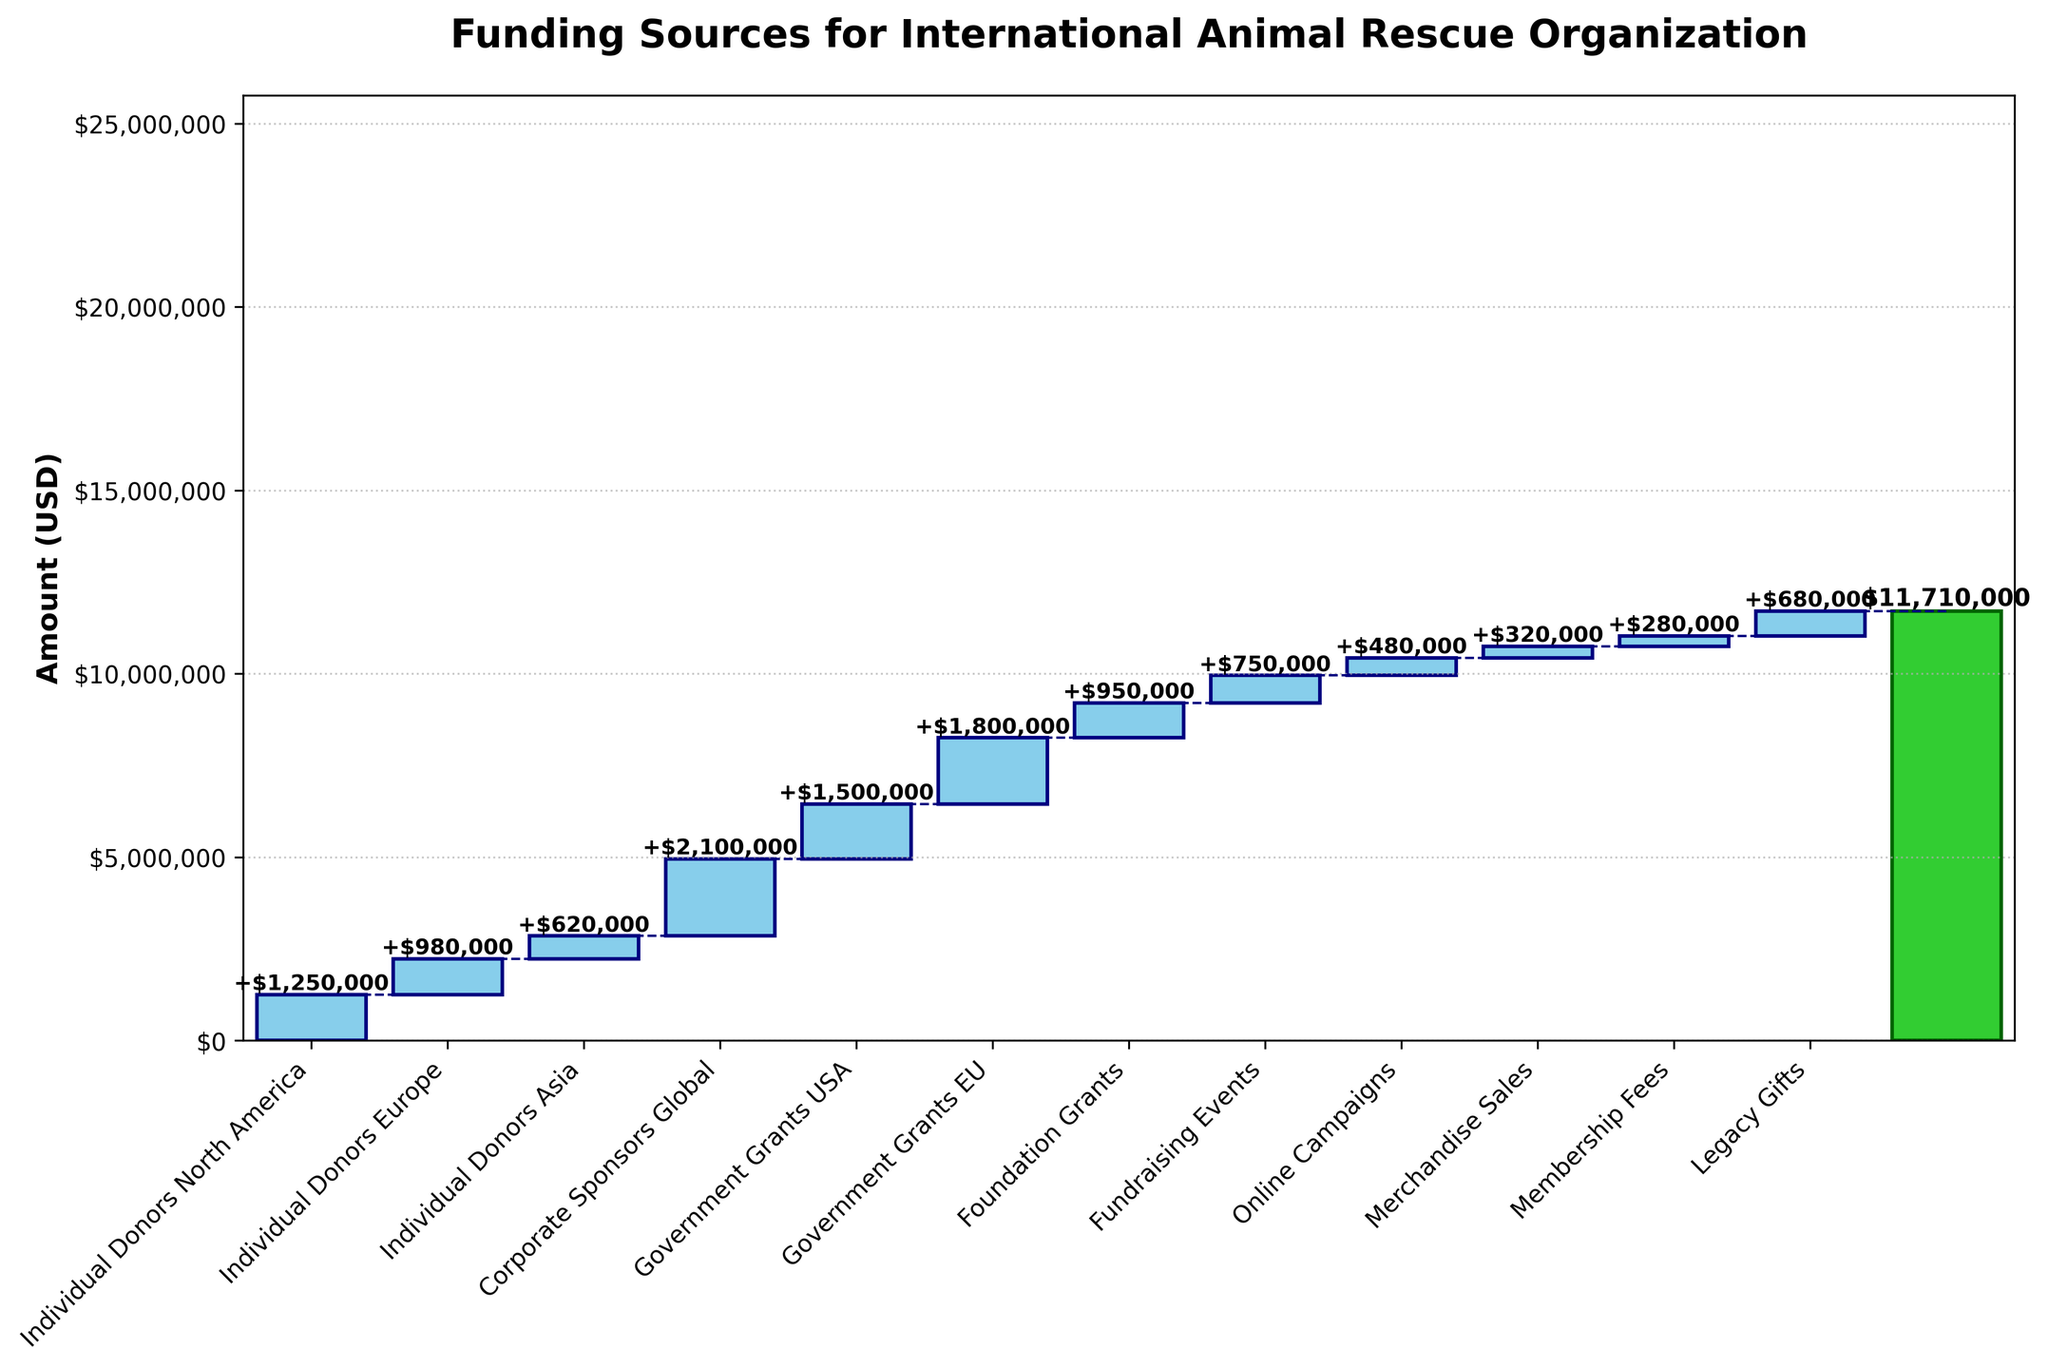what is the title of the plot? The title of the plot is at the top, indicating what the chart represents. It reads, "Funding Sources for International Animal Rescue Organization."
Answer: Funding Sources for International Animal Rescue Organization What is the color used for positive amounts in the bars? The color used for positive amounts in the bars is explicitly seen in the chart as "skyblue."
Answer: skyblue Which category contributed the most to the funding? By looking at the heights of the bars, "Corporate Sponsors Global" has the highest amount contributed, as it visually appears the tallest.
Answer: Corporate Sponsors Global What is the total amount of funding from all sources combined? The total amount of funding from all sources combined is shown as the last category labeled "Total," and it contributes a green bar at the end. The label on the bar shows the amount as $11,710,000.
Answer: $11,710,000 How much did Government Grants (USA + EU) contribute together? Sum the amounts of Government Grants USA ($1,500,000) and Government Grants EU ($1,800,000). 1,500,000 + 1,800,000 = 3,300,000
Answer: $3,300,000 Compare the funding amount between Individual Donors North America and Individual Donors Europe. Individual Donors North America contributed $1,250,000 while Individual Donors Europe contributed $980,000. Compare these two amounts.
Answer: Individual Donors North America > Individual Donors Europe What is the difference between the highest and the lowest contributing categories? The highest contributing category is "Corporate Sponsors Global" with $2,100,000 and the lowest is "Membership Fees" with $280,000. The difference is calculated as: 2,100,000 - 280,000 = 1,820,000
Answer: $1,820,000 What is the combined contribution from Individual Donors from all regions? Sum the amounts from Individual Donors North America ($1,250,000), Individual Donors Europe ($980,000), and Individual Donors Asia ($620,000). 1,250,000 + 980,000 + 620,000 = 2,850,000
Answer: $2,850,000 Which category other than the total shows a positive amount closest to $1,000,000? By checking the amounts, "Foundation Grants" with $950,000 is the closest positive amount to $1,000,000.
Answer: Foundation Grants 